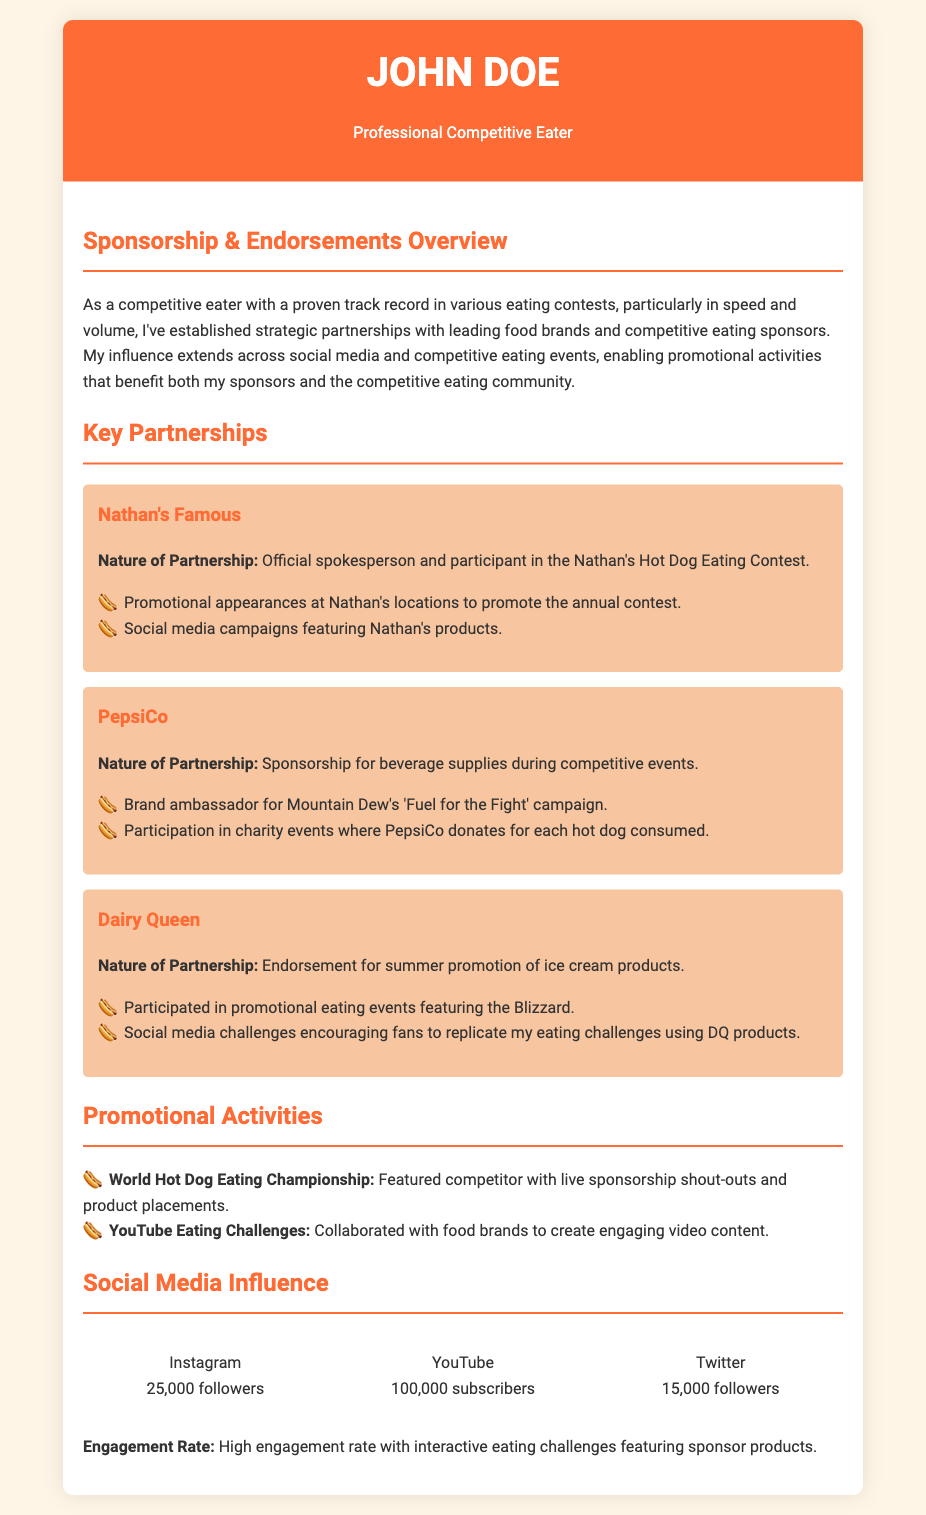what is the name of the professional competitive eater? The name provided in the document is "John Doe".
Answer: John Doe how many followers does John Doe have on Instagram? The document states that John Doe has 25,000 followers on Instagram.
Answer: 25,000 who is the official spokesperson for Nathan's? The document indicates John Doe is the official spokesperson for Nathan's.
Answer: John Doe what beverage brand sponsors John Doe during competitive events? According to the document, PepsiCo provides sponsorship for beverages.
Answer: PepsiCo what is the engagement rate described in the document? The document mentions a high engagement rate with interactive eating challenges.
Answer: High engagement rate which competitive eating contest does John Doe participate in as indicated in the document? The document highlights participation in the World Hot Dog Eating Championship.
Answer: World Hot Dog Eating Championship how many subscribers does John Doe have on YouTube? The document states that John Doe has 100,000 subscribers on YouTube.
Answer: 100,000 what type of product is promoted by Dairy Queen through their partnership? The document states that Dairy Queen promotes ice cream products.
Answer: Ice cream products what activity does John Doe do to promote Nathan's products? The document mentions promotional appearances at Nathan's locations.
Answer: Promotional appearances 